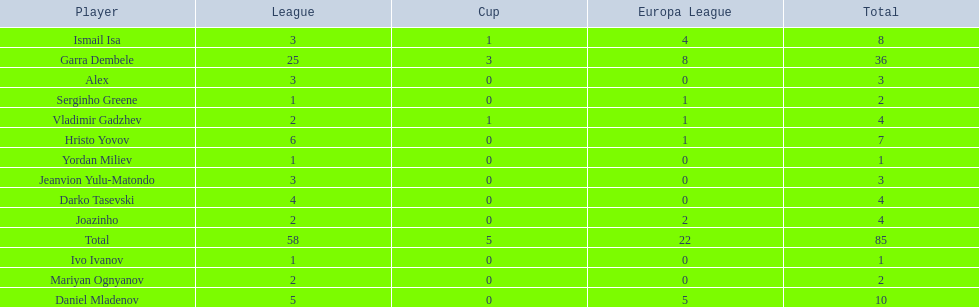Which total is higher, the europa league total or the league total? League. Could you parse the entire table as a dict? {'header': ['Player', 'League', 'Cup', 'Europa League', 'Total'], 'rows': [['Ismail Isa', '3', '1', '4', '8'], ['Garra Dembele', '25', '3', '8', '36'], ['Alex', '3', '0', '0', '3'], ['Serginho Greene', '1', '0', '1', '2'], ['Vladimir Gadzhev', '2', '1', '1', '4'], ['Hristo Yovov', '6', '0', '1', '7'], ['Yordan Miliev', '1', '0', '0', '1'], ['Jeanvion Yulu-Matondo', '3', '0', '0', '3'], ['Darko Tasevski', '4', '0', '0', '4'], ['Joazinho', '2', '0', '2', '4'], ['Total', '58', '5', '22', '85'], ['Ivo Ivanov', '1', '0', '0', '1'], ['Mariyan Ognyanov', '2', '0', '0', '2'], ['Daniel Mladenov', '5', '0', '5', '10']]} 